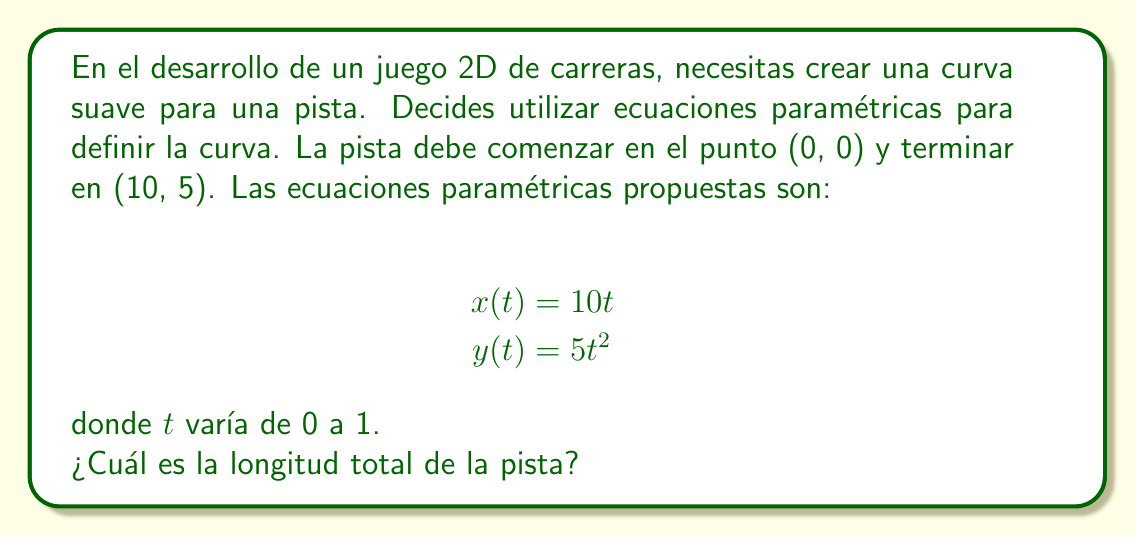Could you help me with this problem? Para calcular la longitud de una curva definida por ecuaciones paramétricas, utilizamos la fórmula:

$$L = \int_a^b \sqrt{\left(\frac{dx}{dt}\right)^2 + \left(\frac{dy}{dt}\right)^2} dt$$

donde $a$ y $b$ son los límites del parámetro $t$.

Paso 1: Calcular las derivadas
$$\frac{dx}{dt} = 10$$
$$\frac{dy}{dt} = 10t$$

Paso 2: Sustituir en la fórmula de la longitud
$$L = \int_0^1 \sqrt{10^2 + (10t)^2} dt$$

Paso 3: Simplificar
$$L = \int_0^1 \sqrt{100 + 100t^2} dt$$
$$L = 10\int_0^1 \sqrt{1 + t^2} dt$$

Paso 4: Esta integral no tiene una solución elemental. Podemos resolverla utilizando la sustitución $t = \tan\theta$:

$$L = 10\int_0^{\pi/4} \sqrt{1 + \tan^2\theta} \sec^2\theta d\theta$$
$$L = 10\int_0^{\pi/4} \sec^3\theta d\theta$$

Paso 5: La integral de $\sec^3\theta$ es:

$$\int \sec^3\theta d\theta = \frac{1}{2}(\tan\theta\sec\theta + \ln|\tan\theta + \sec\theta|) + C$$

Paso 6: Evaluar los límites
$$L = 5(\tan\frac{\pi}{4}\sec\frac{\pi}{4} + \ln|\tan\frac{\pi}{4} + \sec\frac{\pi}{4}|) - 5(0 + \ln|0 + 1|)$$

Paso 7: Simplificar
$$L = 5(\sqrt{2} + \ln(\sqrt{2} + 1))$$
Answer: La longitud total de la pista es $5(\sqrt{2} + \ln(\sqrt{2} + 1))$ unidades. 